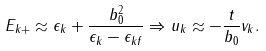<formula> <loc_0><loc_0><loc_500><loc_500>E _ { k + } \approx \epsilon _ { k } + \frac { b _ { 0 } ^ { 2 } } { \epsilon _ { k } - \epsilon _ { k f } } \Rightarrow u _ { k } \approx - \frac { t } { b _ { 0 } } v _ { k } .</formula> 